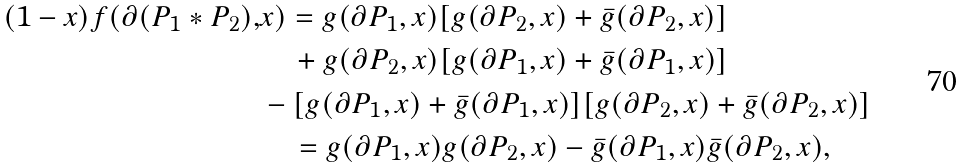Convert formula to latex. <formula><loc_0><loc_0><loc_500><loc_500>( 1 - x ) f ( \partial ( P _ { 1 } * P _ { 2 } ) , & x ) = g ( \partial P _ { 1 } , x ) [ g ( \partial P _ { 2 } , x ) + \bar { g } ( \partial P _ { 2 } , x ) ] \\ & \quad + g ( \partial P _ { 2 } , x ) [ g ( \partial P _ { 1 } , x ) + \bar { g } ( \partial P _ { 1 } , x ) ] \\ & - [ g ( \partial P _ { 1 } , x ) + \bar { g } ( \partial P _ { 1 } , x ) ] [ g ( \partial P _ { 2 } , x ) + \bar { g } ( \partial P _ { 2 } , x ) ] \\ & \quad = g ( \partial P _ { 1 } , x ) g ( \partial P _ { 2 } , x ) - \bar { g } ( \partial P _ { 1 } , x ) \bar { g } ( \partial P _ { 2 } , x ) ,</formula> 